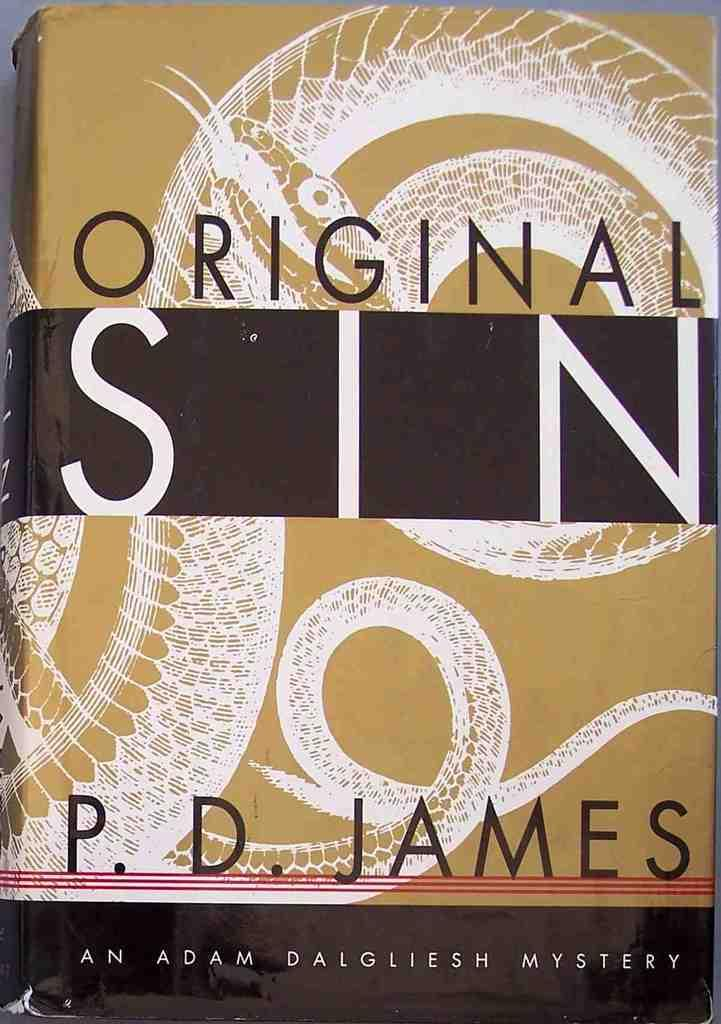What is the main object in the image? There is a book in the image. What is the title of the book? The book is titled "Original Sin." Who is the author of the book? The author of the book is P. D. James. What type of nut is used as a vessel for the book's contents in the image? There is no nut or vessel present in the image; it features a book with a title and an author. 